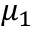<formula> <loc_0><loc_0><loc_500><loc_500>\mu _ { 1 }</formula> 